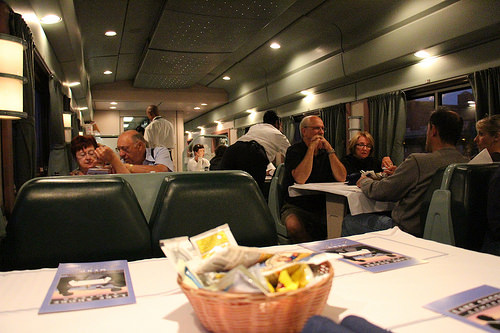<image>
Is there a man to the right of the woman? No. The man is not to the right of the woman. The horizontal positioning shows a different relationship. 